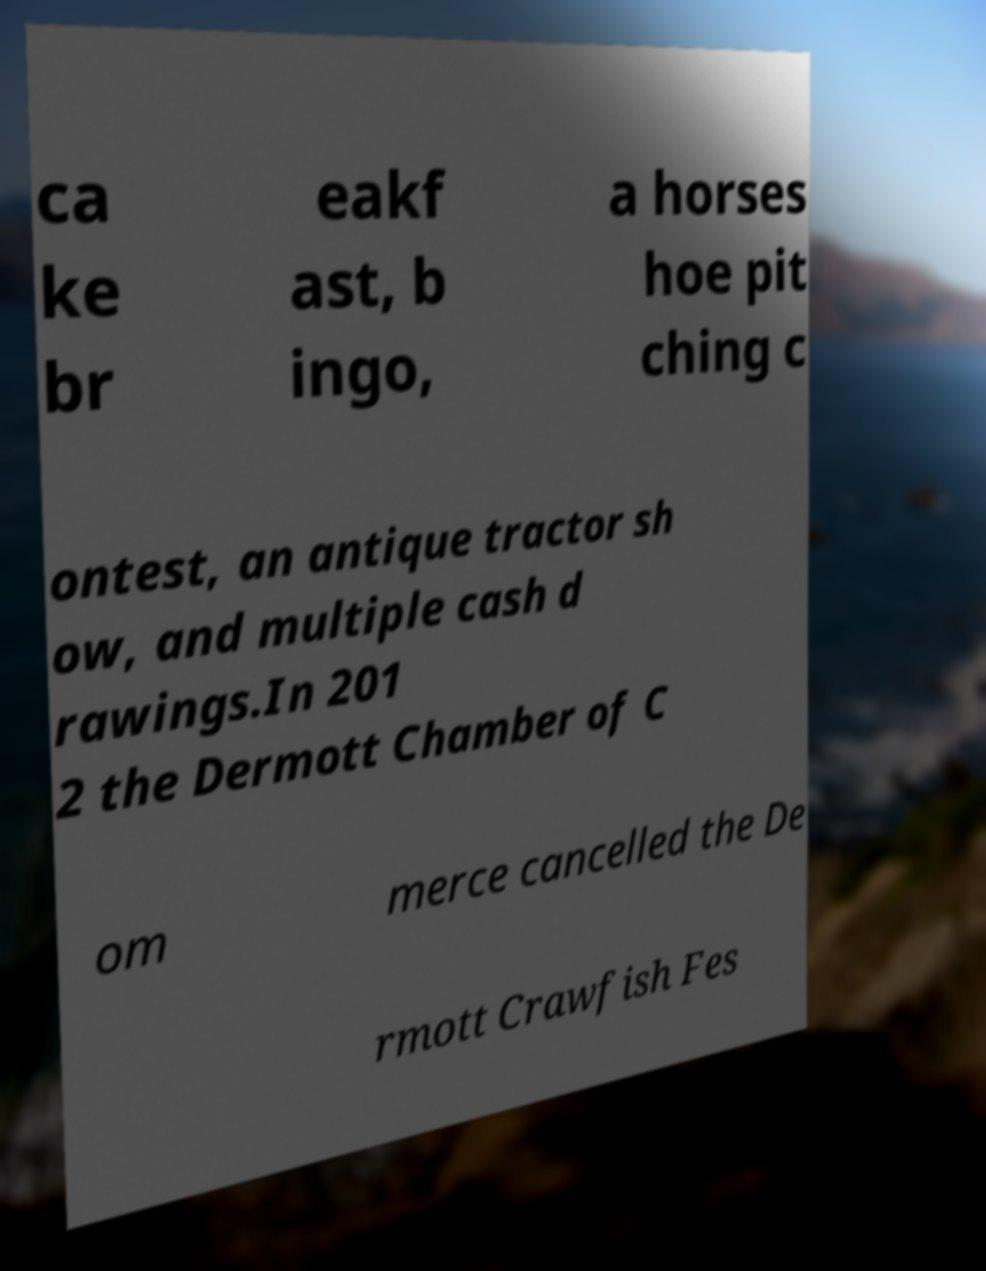For documentation purposes, I need the text within this image transcribed. Could you provide that? ca ke br eakf ast, b ingo, a horses hoe pit ching c ontest, an antique tractor sh ow, and multiple cash d rawings.In 201 2 the Dermott Chamber of C om merce cancelled the De rmott Crawfish Fes 